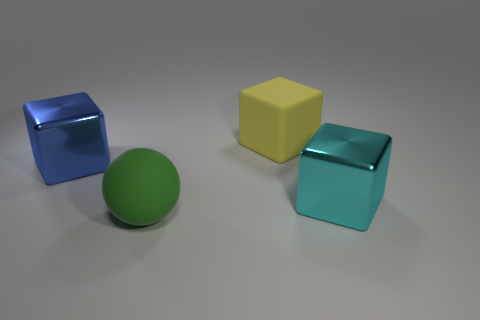Subtract all large shiny blocks. How many blocks are left? 1 Add 3 large yellow matte cubes. How many objects exist? 7 Subtract all blue cubes. How many cubes are left? 2 Subtract all blocks. How many objects are left? 1 Subtract all blue cylinders. How many blue cubes are left? 1 Add 3 rubber things. How many rubber things are left? 5 Add 1 big red shiny things. How many big red shiny things exist? 1 Subtract 0 purple blocks. How many objects are left? 4 Subtract all yellow cubes. Subtract all purple cylinders. How many cubes are left? 2 Subtract all large cyan shiny cubes. Subtract all small objects. How many objects are left? 3 